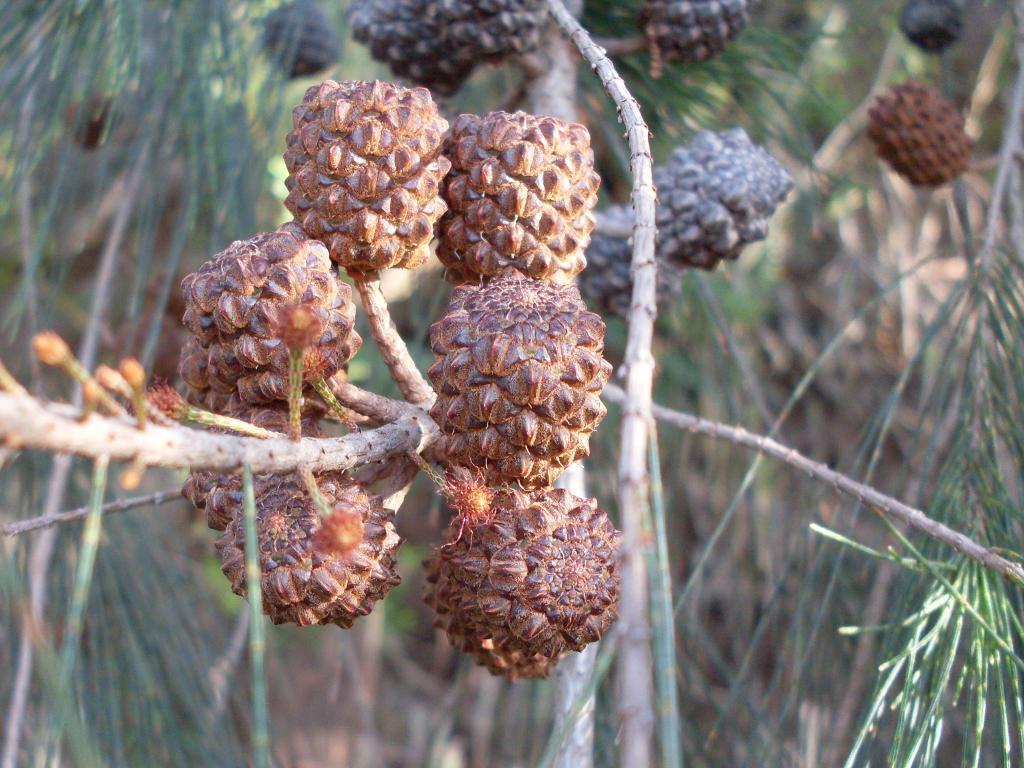How would you summarize this image in a sentence or two? In this image we can see fruit on the branch of the tree and leaves are there. 